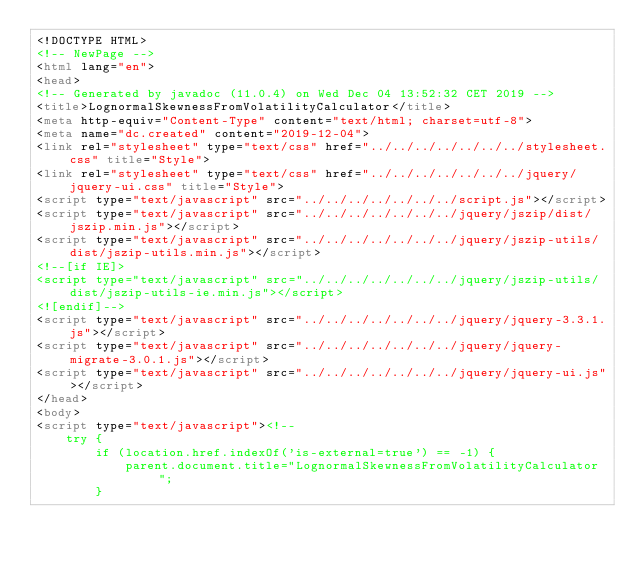<code> <loc_0><loc_0><loc_500><loc_500><_HTML_><!DOCTYPE HTML>
<!-- NewPage -->
<html lang="en">
<head>
<!-- Generated by javadoc (11.0.4) on Wed Dec 04 13:52:32 CET 2019 -->
<title>LognormalSkewnessFromVolatilityCalculator</title>
<meta http-equiv="Content-Type" content="text/html; charset=utf-8">
<meta name="dc.created" content="2019-12-04">
<link rel="stylesheet" type="text/css" href="../../../../../../../stylesheet.css" title="Style">
<link rel="stylesheet" type="text/css" href="../../../../../../../jquery/jquery-ui.css" title="Style">
<script type="text/javascript" src="../../../../../../../script.js"></script>
<script type="text/javascript" src="../../../../../../../jquery/jszip/dist/jszip.min.js"></script>
<script type="text/javascript" src="../../../../../../../jquery/jszip-utils/dist/jszip-utils.min.js"></script>
<!--[if IE]>
<script type="text/javascript" src="../../../../../../../jquery/jszip-utils/dist/jszip-utils-ie.min.js"></script>
<![endif]-->
<script type="text/javascript" src="../../../../../../../jquery/jquery-3.3.1.js"></script>
<script type="text/javascript" src="../../../../../../../jquery/jquery-migrate-3.0.1.js"></script>
<script type="text/javascript" src="../../../../../../../jquery/jquery-ui.js"></script>
</head>
<body>
<script type="text/javascript"><!--
    try {
        if (location.href.indexOf('is-external=true') == -1) {
            parent.document.title="LognormalSkewnessFromVolatilityCalculator";
        }</code> 